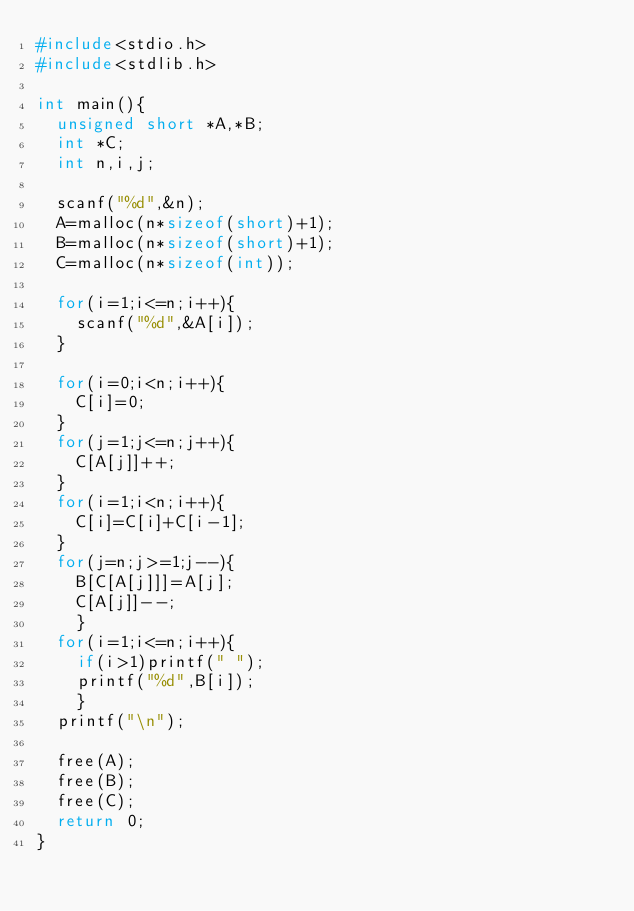<code> <loc_0><loc_0><loc_500><loc_500><_C_>#include<stdio.h>
#include<stdlib.h>

int main(){
  unsigned short *A,*B;
  int *C;
  int n,i,j;

  scanf("%d",&n);
  A=malloc(n*sizeof(short)+1);
  B=malloc(n*sizeof(short)+1);
  C=malloc(n*sizeof(int));
  
  for(i=1;i<=n;i++){
    scanf("%d",&A[i]);
  }
  
  for(i=0;i<n;i++){
    C[i]=0;
  }
  for(j=1;j<=n;j++){
    C[A[j]]++;
  }
  for(i=1;i<n;i++){
    C[i]=C[i]+C[i-1];
  }
  for(j=n;j>=1;j--){
    B[C[A[j]]]=A[j];
    C[A[j]]--;
    }
  for(i=1;i<=n;i++){
    if(i>1)printf(" ");
    printf("%d",B[i]);
    }
  printf("\n");
  
  free(A);
  free(B);
  free(C);
  return 0;
}


</code> 